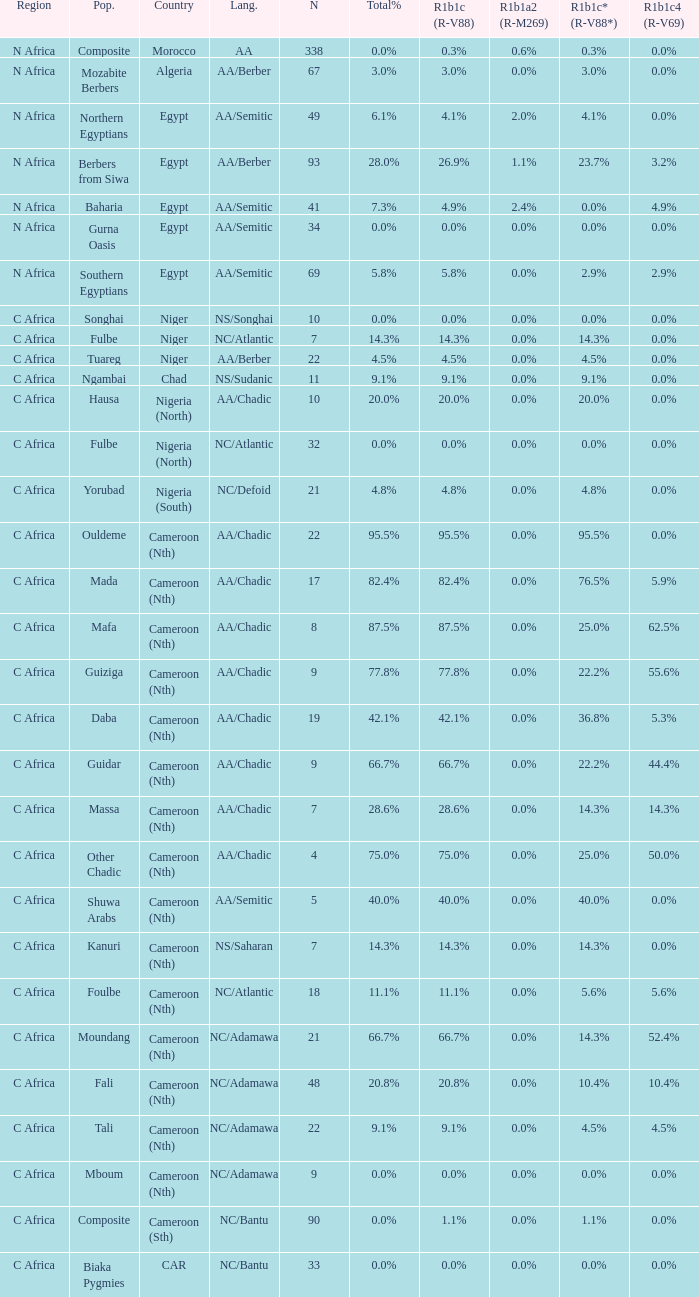Give me the full table as a dictionary. {'header': ['Region', 'Pop.', 'Country', 'Lang.', 'N', 'Total%', 'R1b1c (R-V88)', 'R1b1a2 (R-M269)', 'R1b1c* (R-V88*)', 'R1b1c4 (R-V69)'], 'rows': [['N Africa', 'Composite', 'Morocco', 'AA', '338', '0.0%', '0.3%', '0.6%', '0.3%', '0.0%'], ['N Africa', 'Mozabite Berbers', 'Algeria', 'AA/Berber', '67', '3.0%', '3.0%', '0.0%', '3.0%', '0.0%'], ['N Africa', 'Northern Egyptians', 'Egypt', 'AA/Semitic', '49', '6.1%', '4.1%', '2.0%', '4.1%', '0.0%'], ['N Africa', 'Berbers from Siwa', 'Egypt', 'AA/Berber', '93', '28.0%', '26.9%', '1.1%', '23.7%', '3.2%'], ['N Africa', 'Baharia', 'Egypt', 'AA/Semitic', '41', '7.3%', '4.9%', '2.4%', '0.0%', '4.9%'], ['N Africa', 'Gurna Oasis', 'Egypt', 'AA/Semitic', '34', '0.0%', '0.0%', '0.0%', '0.0%', '0.0%'], ['N Africa', 'Southern Egyptians', 'Egypt', 'AA/Semitic', '69', '5.8%', '5.8%', '0.0%', '2.9%', '2.9%'], ['C Africa', 'Songhai', 'Niger', 'NS/Songhai', '10', '0.0%', '0.0%', '0.0%', '0.0%', '0.0%'], ['C Africa', 'Fulbe', 'Niger', 'NC/Atlantic', '7', '14.3%', '14.3%', '0.0%', '14.3%', '0.0%'], ['C Africa', 'Tuareg', 'Niger', 'AA/Berber', '22', '4.5%', '4.5%', '0.0%', '4.5%', '0.0%'], ['C Africa', 'Ngambai', 'Chad', 'NS/Sudanic', '11', '9.1%', '9.1%', '0.0%', '9.1%', '0.0%'], ['C Africa', 'Hausa', 'Nigeria (North)', 'AA/Chadic', '10', '20.0%', '20.0%', '0.0%', '20.0%', '0.0%'], ['C Africa', 'Fulbe', 'Nigeria (North)', 'NC/Atlantic', '32', '0.0%', '0.0%', '0.0%', '0.0%', '0.0%'], ['C Africa', 'Yorubad', 'Nigeria (South)', 'NC/Defoid', '21', '4.8%', '4.8%', '0.0%', '4.8%', '0.0%'], ['C Africa', 'Ouldeme', 'Cameroon (Nth)', 'AA/Chadic', '22', '95.5%', '95.5%', '0.0%', '95.5%', '0.0%'], ['C Africa', 'Mada', 'Cameroon (Nth)', 'AA/Chadic', '17', '82.4%', '82.4%', '0.0%', '76.5%', '5.9%'], ['C Africa', 'Mafa', 'Cameroon (Nth)', 'AA/Chadic', '8', '87.5%', '87.5%', '0.0%', '25.0%', '62.5%'], ['C Africa', 'Guiziga', 'Cameroon (Nth)', 'AA/Chadic', '9', '77.8%', '77.8%', '0.0%', '22.2%', '55.6%'], ['C Africa', 'Daba', 'Cameroon (Nth)', 'AA/Chadic', '19', '42.1%', '42.1%', '0.0%', '36.8%', '5.3%'], ['C Africa', 'Guidar', 'Cameroon (Nth)', 'AA/Chadic', '9', '66.7%', '66.7%', '0.0%', '22.2%', '44.4%'], ['C Africa', 'Massa', 'Cameroon (Nth)', 'AA/Chadic', '7', '28.6%', '28.6%', '0.0%', '14.3%', '14.3%'], ['C Africa', 'Other Chadic', 'Cameroon (Nth)', 'AA/Chadic', '4', '75.0%', '75.0%', '0.0%', '25.0%', '50.0%'], ['C Africa', 'Shuwa Arabs', 'Cameroon (Nth)', 'AA/Semitic', '5', '40.0%', '40.0%', '0.0%', '40.0%', '0.0%'], ['C Africa', 'Kanuri', 'Cameroon (Nth)', 'NS/Saharan', '7', '14.3%', '14.3%', '0.0%', '14.3%', '0.0%'], ['C Africa', 'Foulbe', 'Cameroon (Nth)', 'NC/Atlantic', '18', '11.1%', '11.1%', '0.0%', '5.6%', '5.6%'], ['C Africa', 'Moundang', 'Cameroon (Nth)', 'NC/Adamawa', '21', '66.7%', '66.7%', '0.0%', '14.3%', '52.4%'], ['C Africa', 'Fali', 'Cameroon (Nth)', 'NC/Adamawa', '48', '20.8%', '20.8%', '0.0%', '10.4%', '10.4%'], ['C Africa', 'Tali', 'Cameroon (Nth)', 'NC/Adamawa', '22', '9.1%', '9.1%', '0.0%', '4.5%', '4.5%'], ['C Africa', 'Mboum', 'Cameroon (Nth)', 'NC/Adamawa', '9', '0.0%', '0.0%', '0.0%', '0.0%', '0.0%'], ['C Africa', 'Composite', 'Cameroon (Sth)', 'NC/Bantu', '90', '0.0%', '1.1%', '0.0%', '1.1%', '0.0%'], ['C Africa', 'Biaka Pygmies', 'CAR', 'NC/Bantu', '33', '0.0%', '0.0%', '0.0%', '0.0%', '0.0%']]} What percentage is listed in column r1b1c (r-v88) for the 4.5% total percentage? 4.5%. 